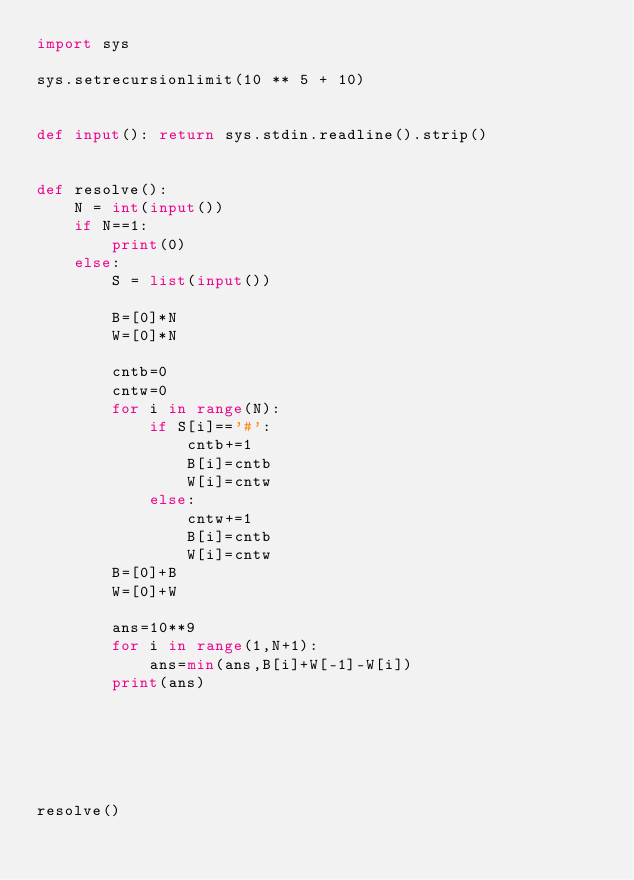<code> <loc_0><loc_0><loc_500><loc_500><_Python_>import sys

sys.setrecursionlimit(10 ** 5 + 10)


def input(): return sys.stdin.readline().strip()


def resolve():
    N = int(input())
    if N==1:
        print(0)
    else:
        S = list(input())

        B=[0]*N
        W=[0]*N

        cntb=0
        cntw=0
        for i in range(N):
            if S[i]=='#':
                cntb+=1
                B[i]=cntb
                W[i]=cntw
            else:
                cntw+=1
                B[i]=cntb
                W[i]=cntw
        B=[0]+B
        W=[0]+W

        ans=10**9
        for i in range(1,N+1):
            ans=min(ans,B[i]+W[-1]-W[i])
        print(ans)






resolve()</code> 